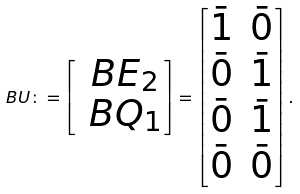<formula> <loc_0><loc_0><loc_500><loc_500>\ B U \colon = \begin{bmatrix} \ B E _ { 2 } \\ \ B Q _ { 1 } \end{bmatrix} = \begin{bmatrix} \bar { 1 } & \bar { 0 } \\ \bar { 0 } & \bar { 1 } \\ \bar { 0 } & \bar { 1 } \\ \bar { 0 } & \bar { 0 } \end{bmatrix} .</formula> 